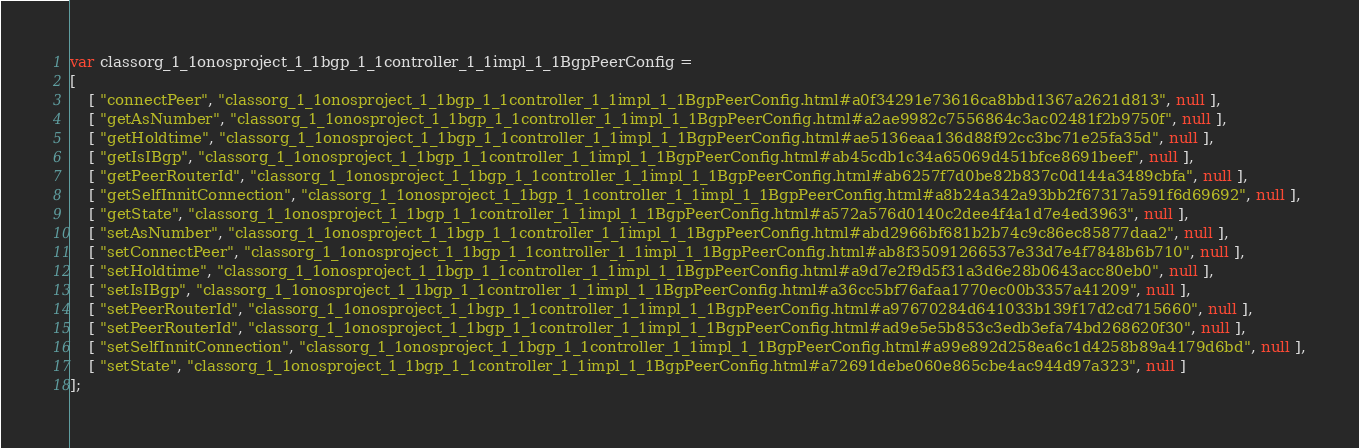<code> <loc_0><loc_0><loc_500><loc_500><_JavaScript_>var classorg_1_1onosproject_1_1bgp_1_1controller_1_1impl_1_1BgpPeerConfig =
[
    [ "connectPeer", "classorg_1_1onosproject_1_1bgp_1_1controller_1_1impl_1_1BgpPeerConfig.html#a0f34291e73616ca8bbd1367a2621d813", null ],
    [ "getAsNumber", "classorg_1_1onosproject_1_1bgp_1_1controller_1_1impl_1_1BgpPeerConfig.html#a2ae9982c7556864c3ac02481f2b9750f", null ],
    [ "getHoldtime", "classorg_1_1onosproject_1_1bgp_1_1controller_1_1impl_1_1BgpPeerConfig.html#ae5136eaa136d88f92cc3bc71e25fa35d", null ],
    [ "getIsIBgp", "classorg_1_1onosproject_1_1bgp_1_1controller_1_1impl_1_1BgpPeerConfig.html#ab45cdb1c34a65069d451bfce8691beef", null ],
    [ "getPeerRouterId", "classorg_1_1onosproject_1_1bgp_1_1controller_1_1impl_1_1BgpPeerConfig.html#ab6257f7d0be82b837c0d144a3489cbfa", null ],
    [ "getSelfInnitConnection", "classorg_1_1onosproject_1_1bgp_1_1controller_1_1impl_1_1BgpPeerConfig.html#a8b24a342a93bb2f67317a591f6d69692", null ],
    [ "getState", "classorg_1_1onosproject_1_1bgp_1_1controller_1_1impl_1_1BgpPeerConfig.html#a572a576d0140c2dee4f4a1d7e4ed3963", null ],
    [ "setAsNumber", "classorg_1_1onosproject_1_1bgp_1_1controller_1_1impl_1_1BgpPeerConfig.html#abd2966bf681b2b74c9c86ec85877daa2", null ],
    [ "setConnectPeer", "classorg_1_1onosproject_1_1bgp_1_1controller_1_1impl_1_1BgpPeerConfig.html#ab8f35091266537e33d7e4f7848b6b710", null ],
    [ "setHoldtime", "classorg_1_1onosproject_1_1bgp_1_1controller_1_1impl_1_1BgpPeerConfig.html#a9d7e2f9d5f31a3d6e28b0643acc80eb0", null ],
    [ "setIsIBgp", "classorg_1_1onosproject_1_1bgp_1_1controller_1_1impl_1_1BgpPeerConfig.html#a36cc5bf76afaa1770ec00b3357a41209", null ],
    [ "setPeerRouterId", "classorg_1_1onosproject_1_1bgp_1_1controller_1_1impl_1_1BgpPeerConfig.html#a97670284d641033b139f17d2cd715660", null ],
    [ "setPeerRouterId", "classorg_1_1onosproject_1_1bgp_1_1controller_1_1impl_1_1BgpPeerConfig.html#ad9e5e5b853c3edb3efa74bd268620f30", null ],
    [ "setSelfInnitConnection", "classorg_1_1onosproject_1_1bgp_1_1controller_1_1impl_1_1BgpPeerConfig.html#a99e892d258ea6c1d4258b89a4179d6bd", null ],
    [ "setState", "classorg_1_1onosproject_1_1bgp_1_1controller_1_1impl_1_1BgpPeerConfig.html#a72691debe060e865cbe4ac944d97a323", null ]
];</code> 